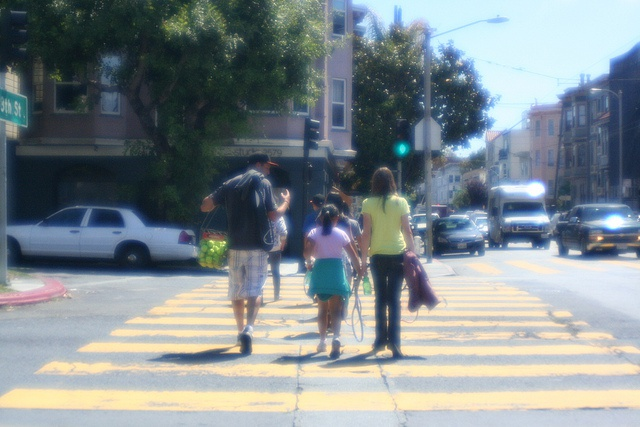Describe the objects in this image and their specific colors. I can see car in black, gray, and navy tones, people in black, darkgray, gray, and navy tones, people in black, olive, gray, and navy tones, people in black, gray, teal, and darkgray tones, and truck in black, white, gray, and darkblue tones in this image. 